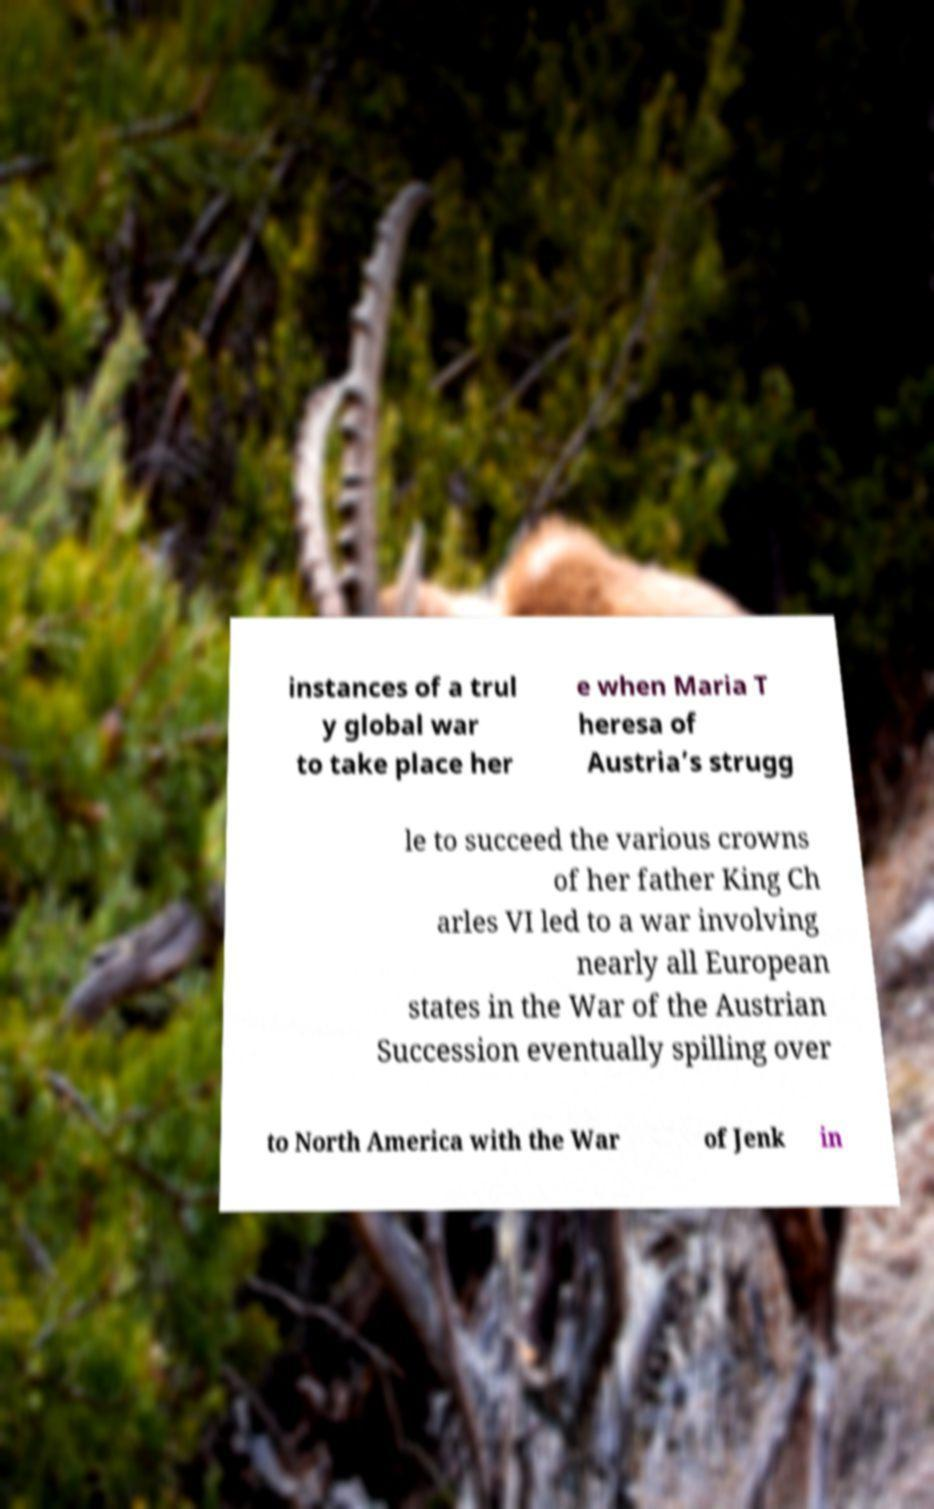Could you extract and type out the text from this image? instances of a trul y global war to take place her e when Maria T heresa of Austria’s strugg le to succeed the various crowns of her father King Ch arles VI led to a war involving nearly all European states in the War of the Austrian Succession eventually spilling over to North America with the War of Jenk in 